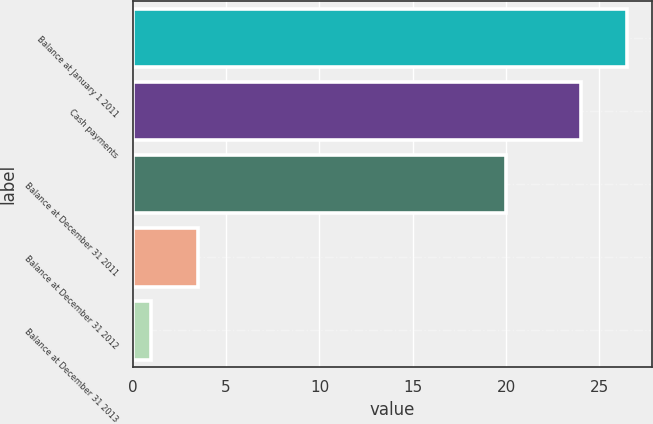Convert chart. <chart><loc_0><loc_0><loc_500><loc_500><bar_chart><fcel>Balance at January 1 2011<fcel>Cash payments<fcel>Balance at December 31 2011<fcel>Balance at December 31 2012<fcel>Balance at December 31 2013<nl><fcel>26.5<fcel>24<fcel>20<fcel>3.5<fcel>1<nl></chart> 